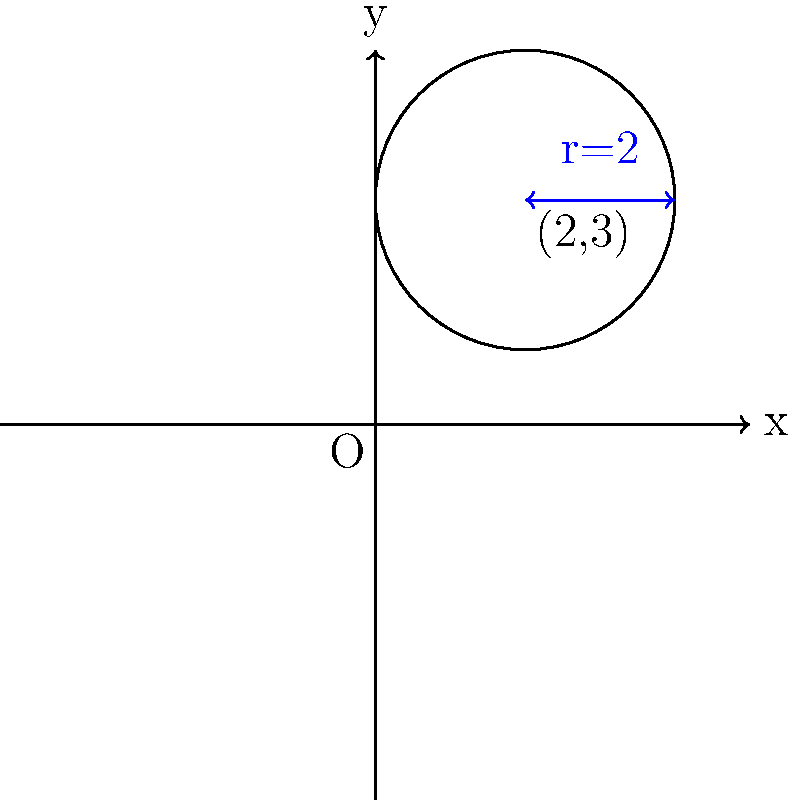In a coordinate system representing daily nutrient intake, a circle is used to visualize the balanced consumption of vitamins and minerals. The center of this circle is located at (2,3) and has a radius of 2 units. Calculate the area of this nutrient intake circle, representing the total daily intake of essential nutrients. Round your answer to two decimal places. To find the area of the circle, we'll follow these steps:

1) The formula for the area of a circle is:
   $$A = \pi r^2$$
   where $A$ is the area and $r$ is the radius.

2) We're given that the radius is 2 units.

3) Let's substitute this into our formula:
   $$A = \pi (2)^2$$

4) Simplify:
   $$A = \pi \cdot 4$$

5) Calculate:
   $$A = 4\pi \approx 12.5663706$$

6) Rounding to two decimal places:
   $$A \approx 12.57$$

Therefore, the area of the nutrient intake circle is approximately 12.57 square units.
Answer: 12.57 square units 